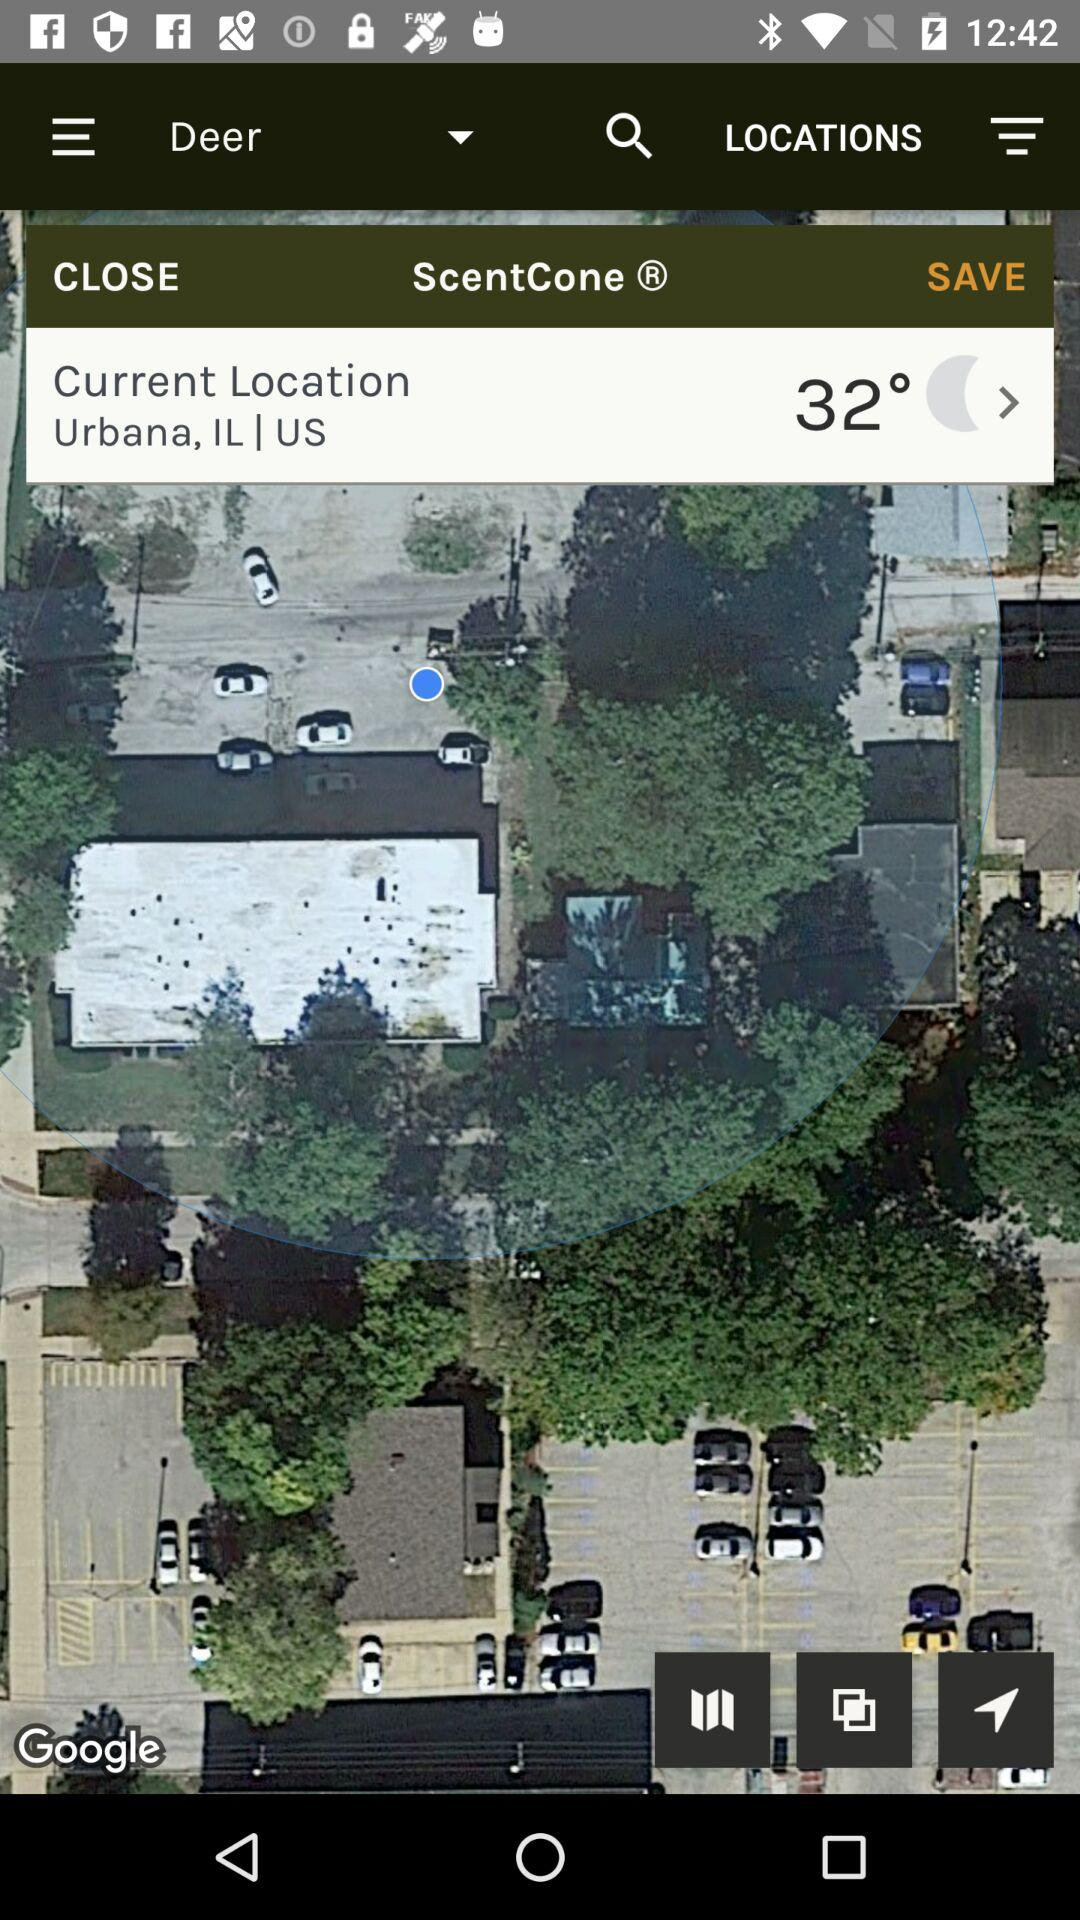What is the weather forecast?
When the provided information is insufficient, respond with <no answer>. <no answer> 